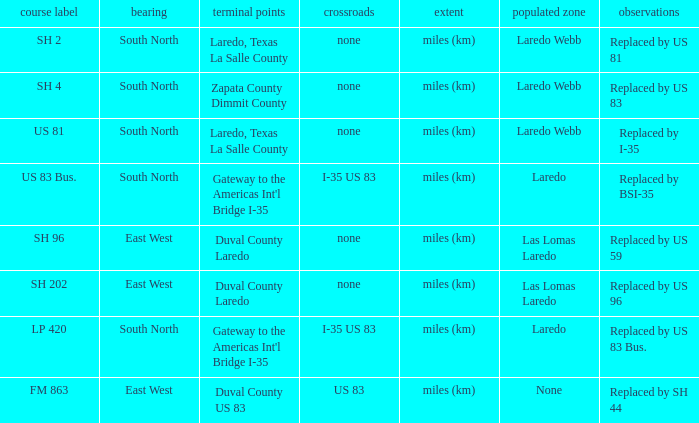Which routes have  "replaced by US 81" listed in their remarks section? SH 2. 